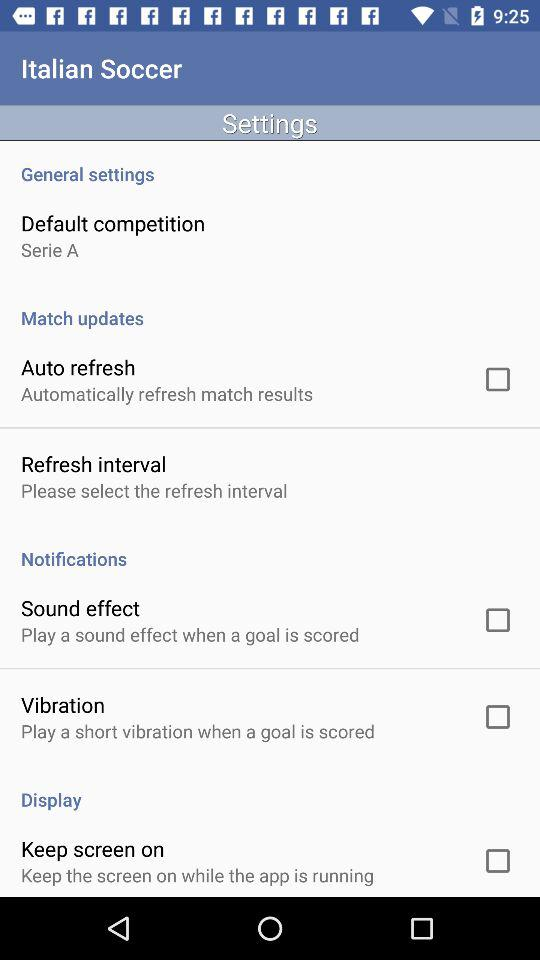Is "Notifications" checked or unchecked?
When the provided information is insufficient, respond with <no answer>. <no answer> 